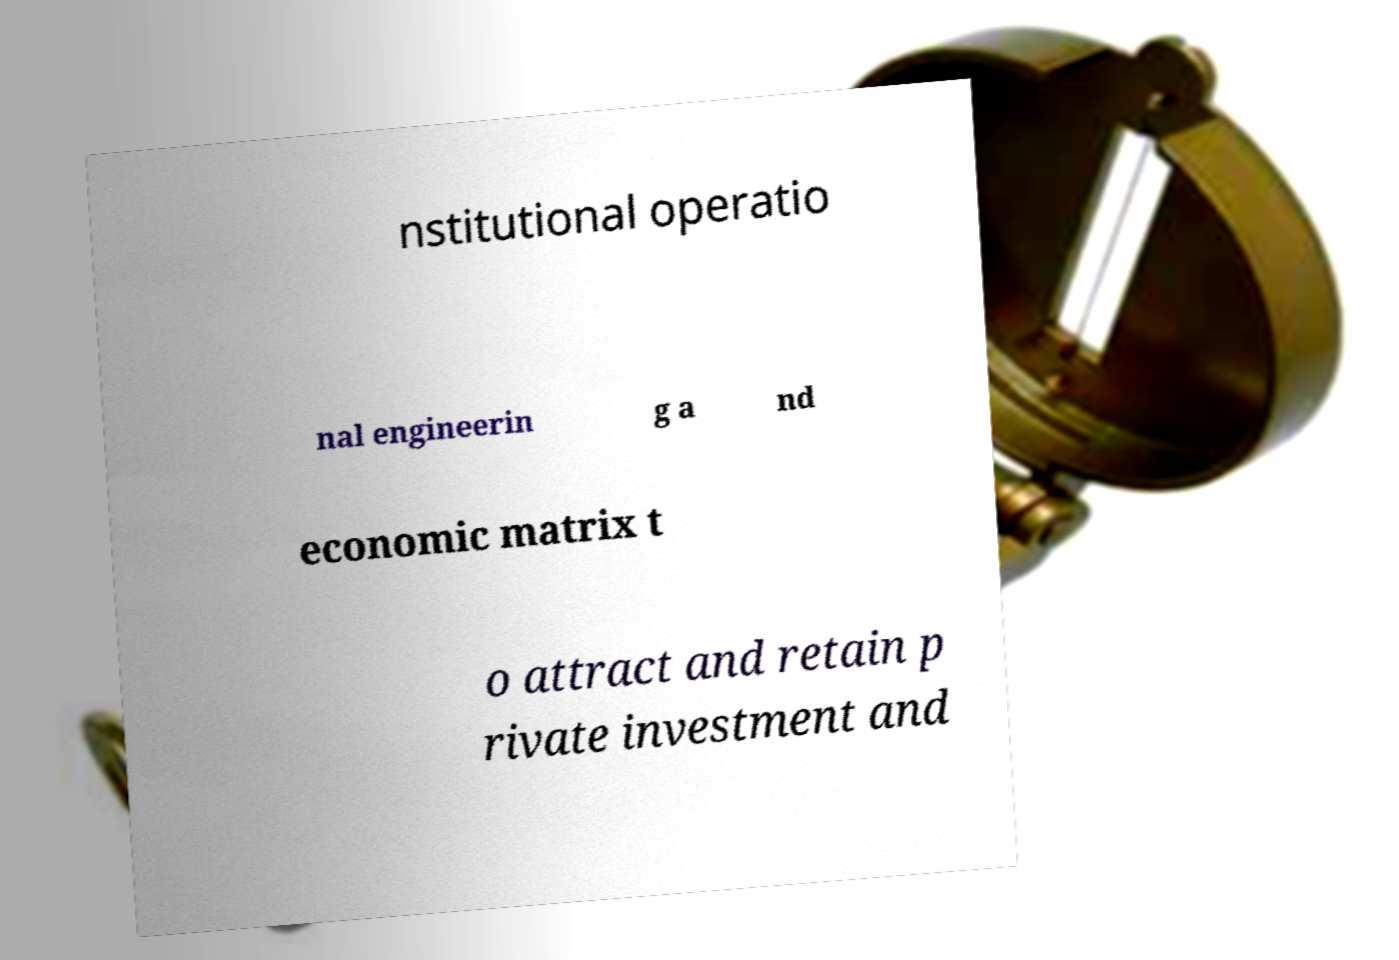Can you read and provide the text displayed in the image?This photo seems to have some interesting text. Can you extract and type it out for me? nstitutional operatio nal engineerin g a nd economic matrix t o attract and retain p rivate investment and 